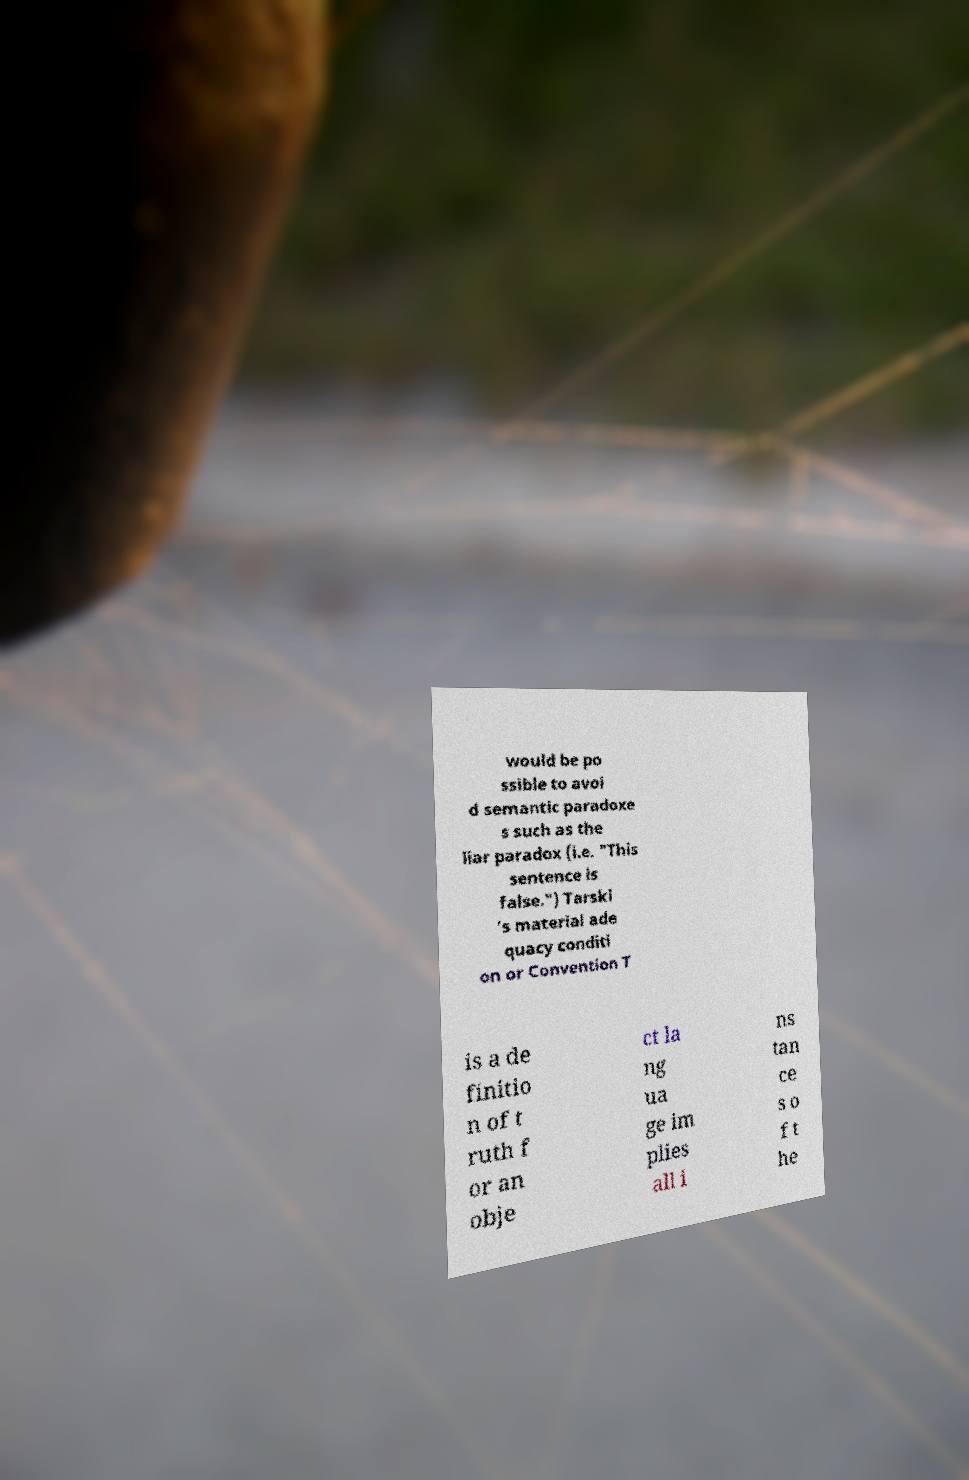Please identify and transcribe the text found in this image. would be po ssible to avoi d semantic paradoxe s such as the liar paradox (i.e. "This sentence is false.") Tarski 's material ade quacy conditi on or Convention T is a de finitio n of t ruth f or an obje ct la ng ua ge im plies all i ns tan ce s o f t he 